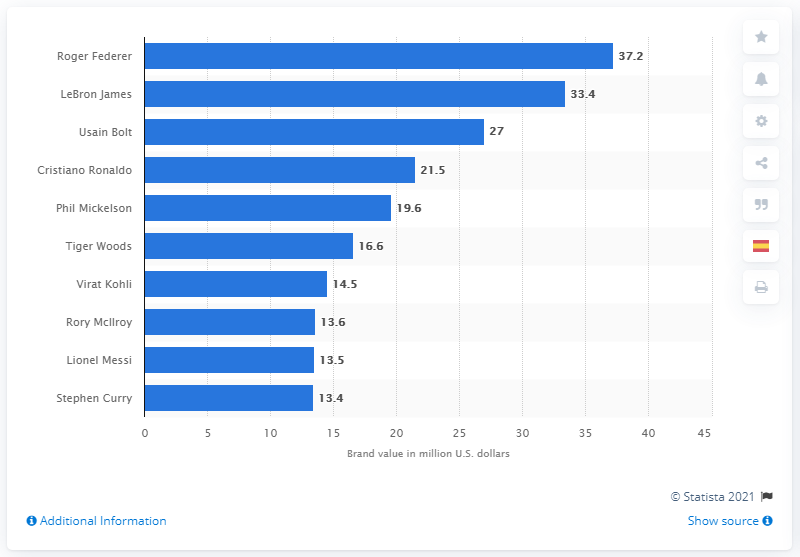Highlight a few significant elements in this photo. Roger Federer was named the most valuable athlete brand in 2017. 